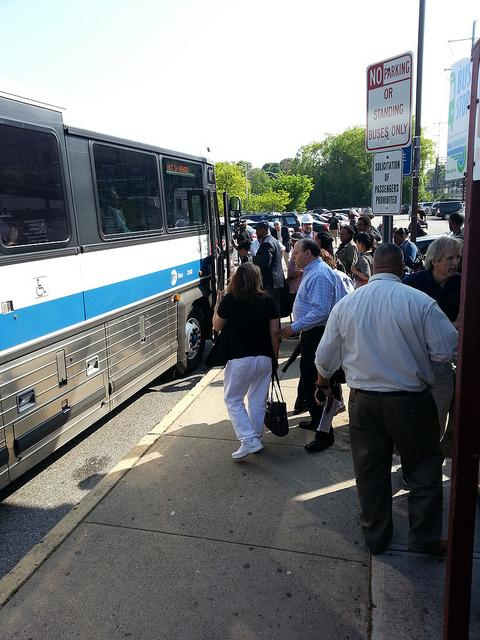What activity is prohibited here? parking 